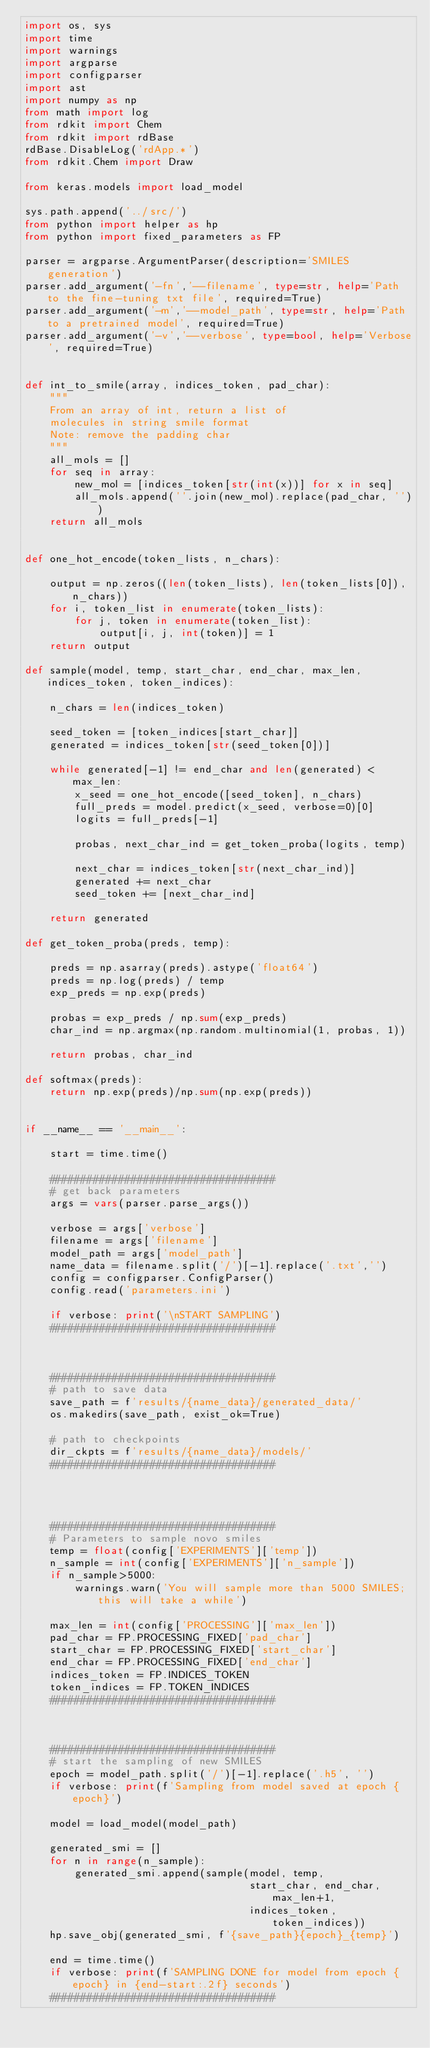<code> <loc_0><loc_0><loc_500><loc_500><_Python_>import os, sys
import time
import warnings
import argparse
import configparser
import ast
import numpy as np
from math import log
from rdkit import Chem
from rdkit import rdBase
rdBase.DisableLog('rdApp.*')
from rdkit.Chem import Draw

from keras.models import load_model

sys.path.append('../src/')
from python import helper as hp
from python import fixed_parameters as FP

parser = argparse.ArgumentParser(description='SMILES generation')
parser.add_argument('-fn','--filename', type=str, help='Path to the fine-tuning txt file', required=True)
parser.add_argument('-m','--model_path', type=str, help='Path to a pretrained model', required=True)
parser.add_argument('-v','--verbose', type=bool, help='Verbose', required=True)


def int_to_smile(array, indices_token, pad_char):
    """ 
    From an array of int, return a list of 
    molecules in string smile format
    Note: remove the padding char
    """
    all_mols = []
    for seq in array:
        new_mol = [indices_token[str(int(x))] for x in seq]
        all_mols.append(''.join(new_mol).replace(pad_char, ''))
    return all_mols


def one_hot_encode(token_lists, n_chars):
    
    output = np.zeros((len(token_lists), len(token_lists[0]), n_chars))
    for i, token_list in enumerate(token_lists):
        for j, token in enumerate(token_list):
            output[i, j, int(token)] = 1
    return output
         
def sample(model, temp, start_char, end_char, max_len, indices_token, token_indices):
    
    n_chars = len(indices_token)

    seed_token = [token_indices[start_char]]
    generated = indices_token[str(seed_token[0])]
    
    while generated[-1] != end_char and len(generated) < max_len:
        x_seed = one_hot_encode([seed_token], n_chars)
        full_preds = model.predict(x_seed, verbose=0)[0]
        logits = full_preds[-1]
        
        probas, next_char_ind = get_token_proba(logits, temp)
                
        next_char = indices_token[str(next_char_ind)]
        generated += next_char
        seed_token += [next_char_ind]
            
    return generated

def get_token_proba(preds, temp):
    
    preds = np.asarray(preds).astype('float64')
    preds = np.log(preds) / temp
    exp_preds = np.exp(preds)
    
    probas = exp_preds / np.sum(exp_preds)
    char_ind = np.argmax(np.random.multinomial(1, probas, 1))
    
    return probas, char_ind

def softmax(preds):
    return np.exp(preds)/np.sum(np.exp(preds))


if __name__ == '__main__':
    
    start = time.time()
    
    ####################################
    # get back parameters
    args = vars(parser.parse_args())
        
    verbose = args['verbose']
    filename = args['filename']
    model_path = args['model_path']
    name_data = filename.split('/')[-1].replace('.txt','')
    config = configparser.ConfigParser()
    config.read('parameters.ini')
    
    if verbose: print('\nSTART SAMPLING')
    ####################################
    
    
    
    ####################################
    # path to save data
    save_path = f'results/{name_data}/generated_data/'
    os.makedirs(save_path, exist_ok=True)
    
    # path to checkpoints
    dir_ckpts = f'results/{name_data}/models/'
    ####################################
    
    
    
    
    ####################################
    # Parameters to sample novo smiles
    temp = float(config['EXPERIMENTS']['temp'])
    n_sample = int(config['EXPERIMENTS']['n_sample'])
    if n_sample>5000:
        warnings.warn('You will sample more than 5000 SMILES; this will take a while')
    
    max_len = int(config['PROCESSING']['max_len'])
    pad_char = FP.PROCESSING_FIXED['pad_char']
    start_char = FP.PROCESSING_FIXED['start_char']
    end_char = FP.PROCESSING_FIXED['end_char']
    indices_token = FP.INDICES_TOKEN
    token_indices = FP.TOKEN_INDICES
    ####################################
    
    
    
    ####################################
    # start the sampling of new SMILES
    epoch = model_path.split('/')[-1].replace('.h5', '')
    if verbose: print(f'Sampling from model saved at epoch {epoch}')
    
    model = load_model(model_path)
    
    generated_smi = []
    for n in range(n_sample):
        generated_smi.append(sample(model, temp, 
                                    start_char, end_char, max_len+1, 
                                    indices_token, token_indices))
    hp.save_obj(generated_smi, f'{save_path}{epoch}_{temp}')
    
    end = time.time()
    if verbose: print(f'SAMPLING DONE for model from epoch {epoch} in {end-start:.2f} seconds')  
    ####################################
        </code> 